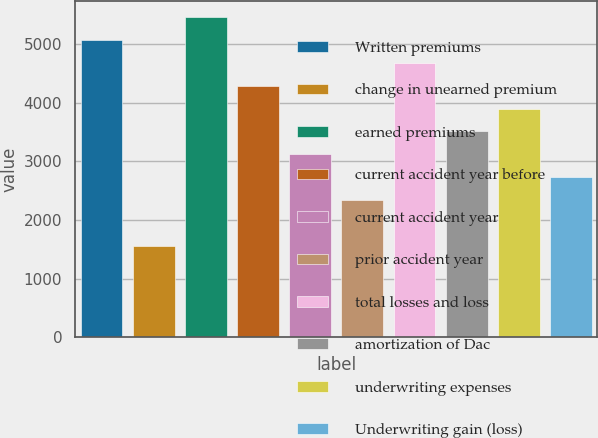<chart> <loc_0><loc_0><loc_500><loc_500><bar_chart><fcel>Written premiums<fcel>change in unearned premium<fcel>earned premiums<fcel>current accident year before<fcel>current accident year<fcel>prior accident year<fcel>total losses and loss<fcel>amortization of Dac<fcel>underwriting expenses<fcel>Underwriting gain (loss)<nl><fcel>5066.8<fcel>1560.4<fcel>5456.4<fcel>4287.6<fcel>3118.8<fcel>2339.6<fcel>4677.2<fcel>3508.4<fcel>3898<fcel>2729.2<nl></chart> 